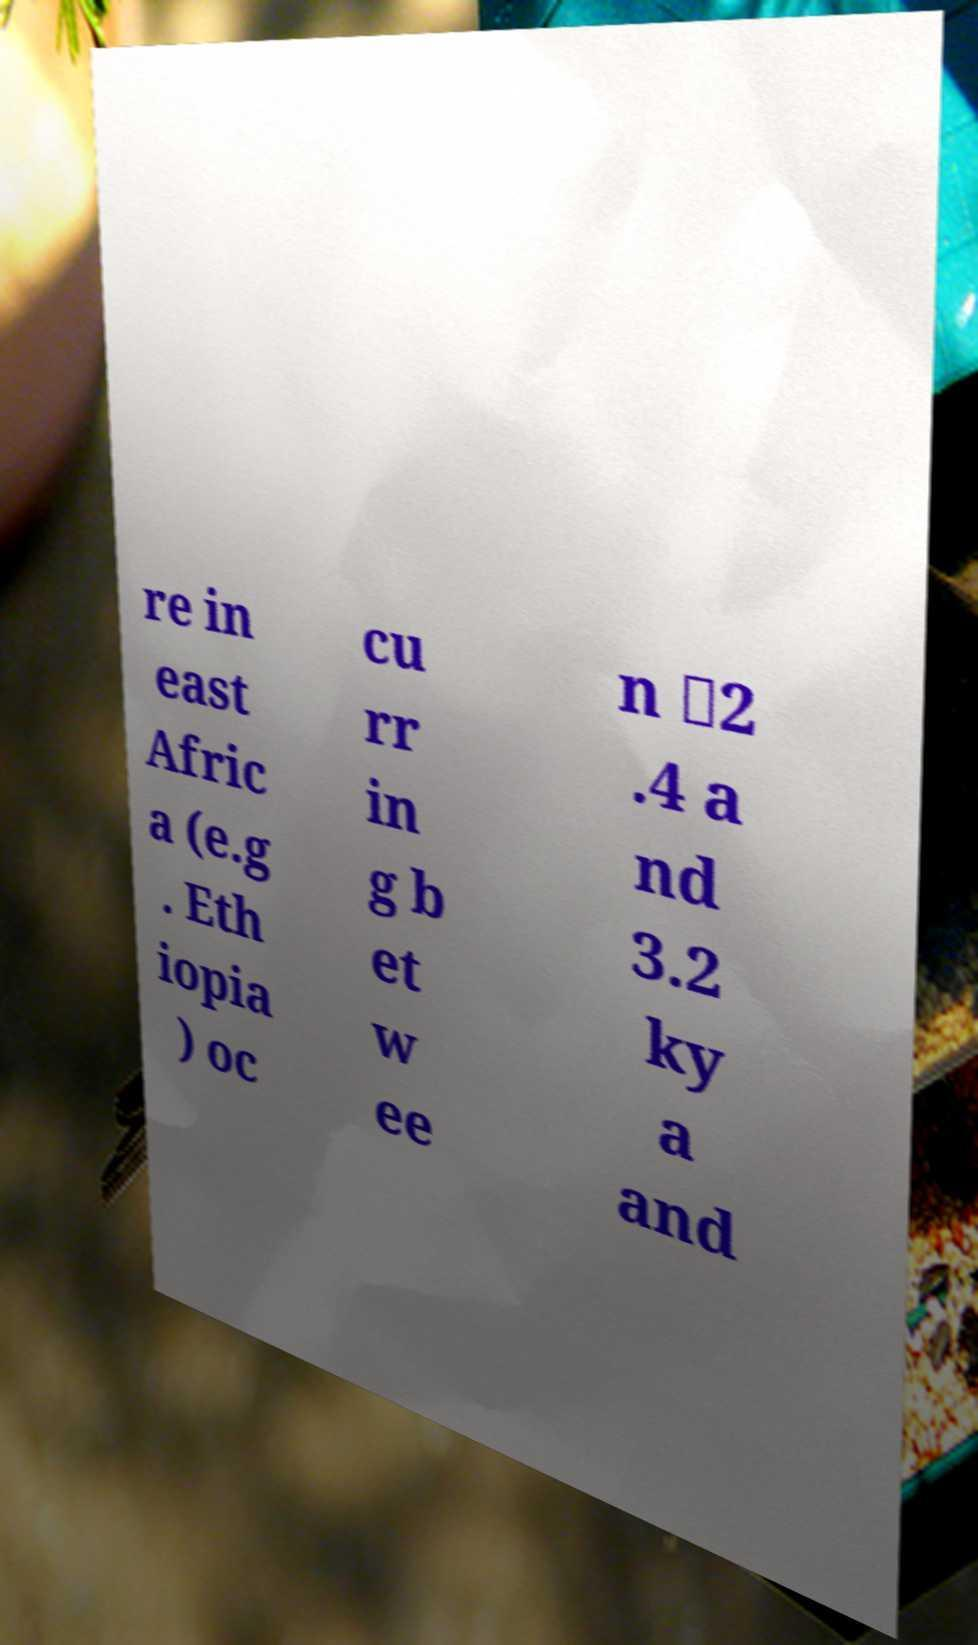Can you read and provide the text displayed in the image?This photo seems to have some interesting text. Can you extract and type it out for me? re in east Afric a (e.g . Eth iopia ) oc cu rr in g b et w ee n ∼2 .4 a nd 3.2 ky a and 